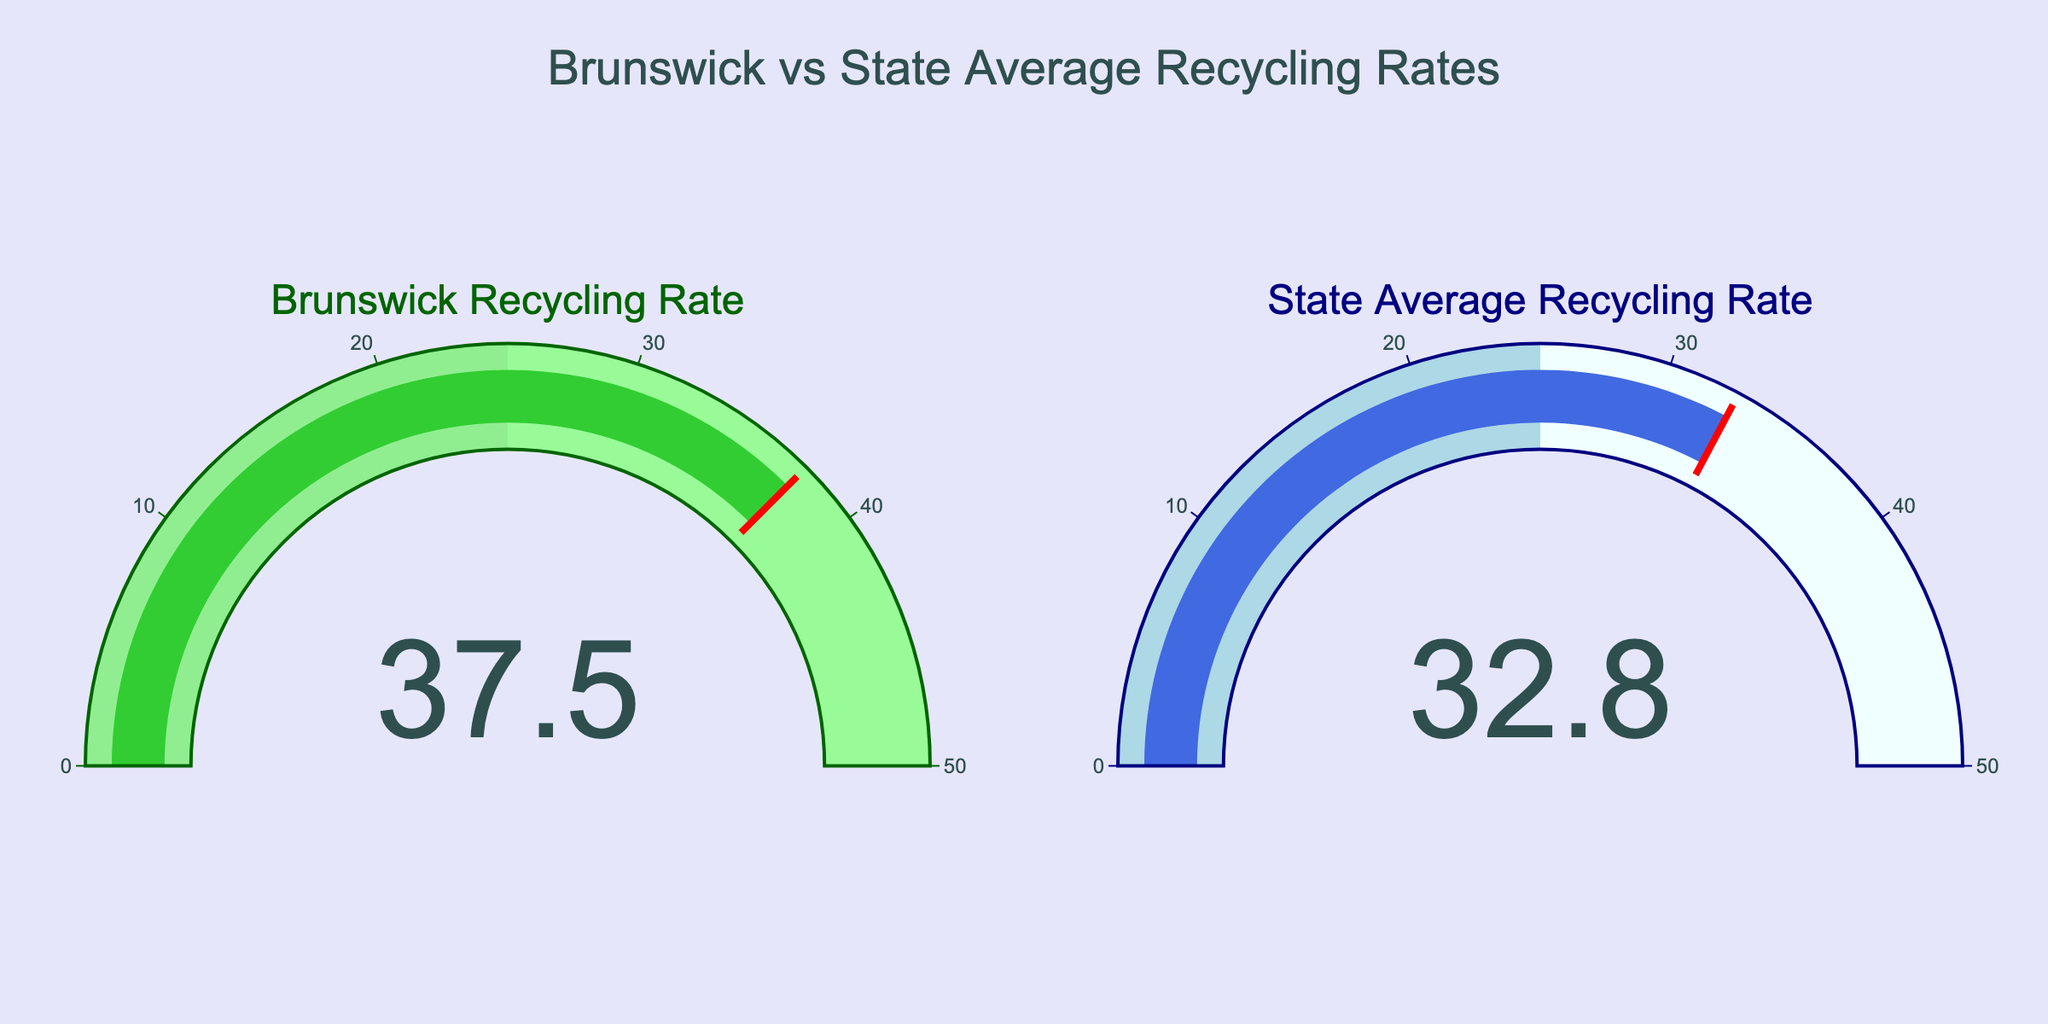What is the recycling rate for Brunswick? The gauge for Brunswick displays a number, which is 37.5.
Answer: 37.5 What is the state average recycling rate? The gauge representing the state average shows a number, which is 32.8.
Answer: 32.8 How much higher is Brunswick's recycling rate compared to the state average? Subtract the state average recycling rate from Brunswick's recycling rate: 37.5 - 32.8 = 4.7.
Answer: 4.7 What is the title of the chart? The title is displayed at the top of the chart and reads "Brunswick vs State Average Recycling Rates."
Answer: Brunswick vs State Average Recycling Rates Does Brunswick have a higher or lower recycling rate compared to the state average? By comparing the numbers in both gauges, Brunswick's recycling rate (37.5) is higher than the state average (32.8).
Answer: Higher What is the highest value on the gauge range for both Brunswick and State Average Recycling Rate? The axis range for both gauges goes up to 50, as indicated by the tick marks.
Answer: 50 What is the color of the bar in Brunswick's gauge? The bar in Brunswick's gauge is colored lime green, as shown by the bar inside the gauge.
Answer: Lime green Which gauge uses the color navy? The gauge for the state average recycling rate uses the color navy, as seen in its title and borders.
Answer: State Average Recycling Rate By how much does Brunswick's recycling rate exceed the threshold value on its gauge? Brunswick's recycling rate threshold is at the same value as the displayed rate (37.5), so it exceeds the threshold by 0.
Answer: 0 Do both gauges have regions marked by different colors? Yes, both gauges have regions with different colors: light green to pale green for Brunswick and light blue to azure for the state average.
Answer: Yes 